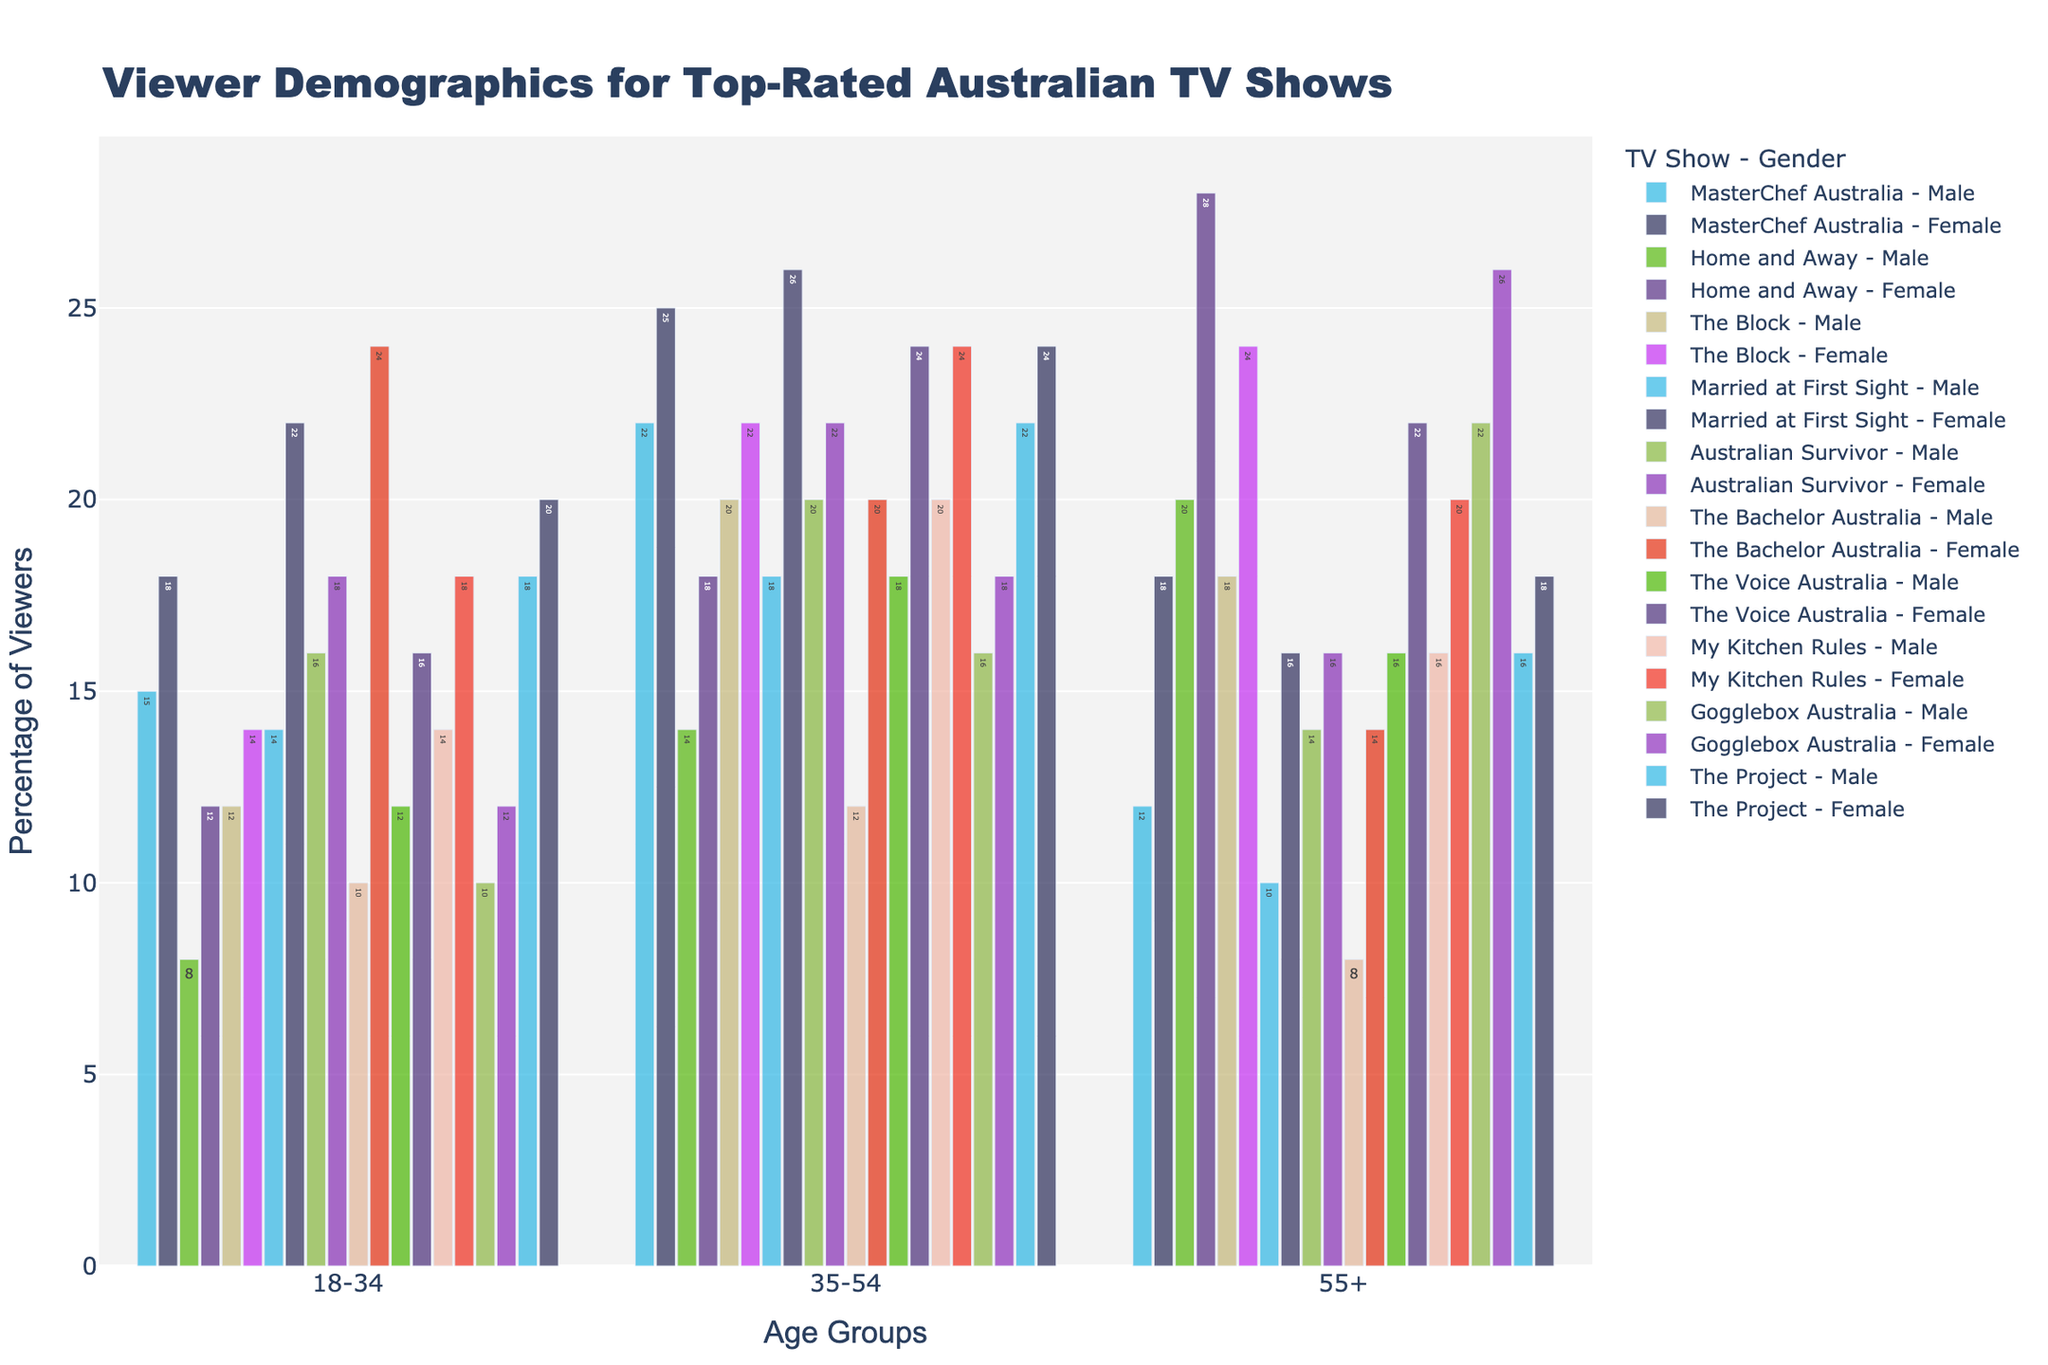Which show has the highest percentage of 18-34 females? From the figure, we see that "The Bachelor Australia" has the highest bar among the 18-34 females group.
Answer: The Bachelor Australia Which age group has the highest percentage of viewers for "Home and Away"? By examining the bars for "Home and Away," the highest percentage is in the 55+ Female group.
Answer: 55+ Female What's the total percentage of viewers aged 35-54 for "Australian Survivor"? Add the percentages for 35-54 Male and 35-54 Female: 20 + 22 = 42
Answer: 42 How does the viewership of 55+ Males compare between "Gogglebox Australia" and "The Project"? Compare the height of the bars for 55+ Males: "Gogglebox Australia" is higher at 22, whereas "The Project" is 16.
Answer: Gogglebox Australia (22) has more Which show has a higher percentage of 18-34 Males, "MasterChef Australia" or "The Project"? By comparing the heights of the bars, "The Project" at 18 is higher than "MasterChef Australia" at 15.
Answer: The Project What is the sum of female viewers aged 18-34 and 35-54 for "Married at First Sight"? Add the percentages for 18-34 Female and 35-54 Female: 22 + 26 = 48
Answer: 48 Which gender has a higher viewership for "The Voice Australia" in the 35-54 age group? For "The Voice Australia," the bar for 35-54 Females (24) is higher than 35-54 Males (18).
Answer: Female What's the difference in viewership between 55+ Females and 55+ Males for "My Kitchen Rules"? Subtract the percentages: 20 - 16 = 4
Answer: 4 Is the viewership percentage higher for 18-34 Females or for 35-54 Males in "The Block"? By comparing the bars, the viewership for 35-54 Males (20) is higher than 18-34 Females (14).
Answer: 35-54 Males Which age group and gender combination has the lowest percentage of viewers for "The Bachelor Australia"? The lowest bar for "The Bachelor Australia" is in the 55+ Male group with 8%.
Answer: 55+ Male 